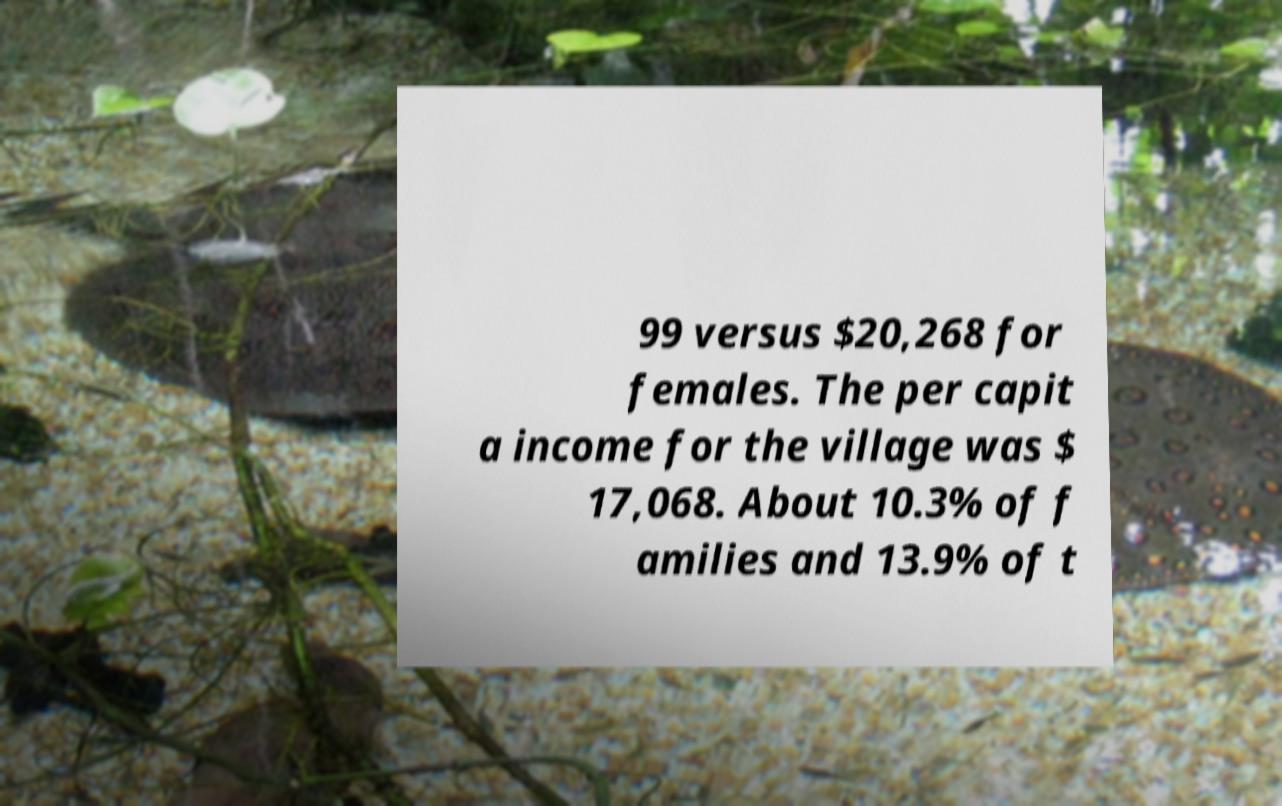Please read and relay the text visible in this image. What does it say? 99 versus $20,268 for females. The per capit a income for the village was $ 17,068. About 10.3% of f amilies and 13.9% of t 